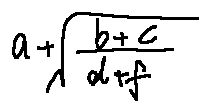Convert formula to latex. <formula><loc_0><loc_0><loc_500><loc_500>a + \sqrt { \frac { b + c } { d + f } }</formula> 